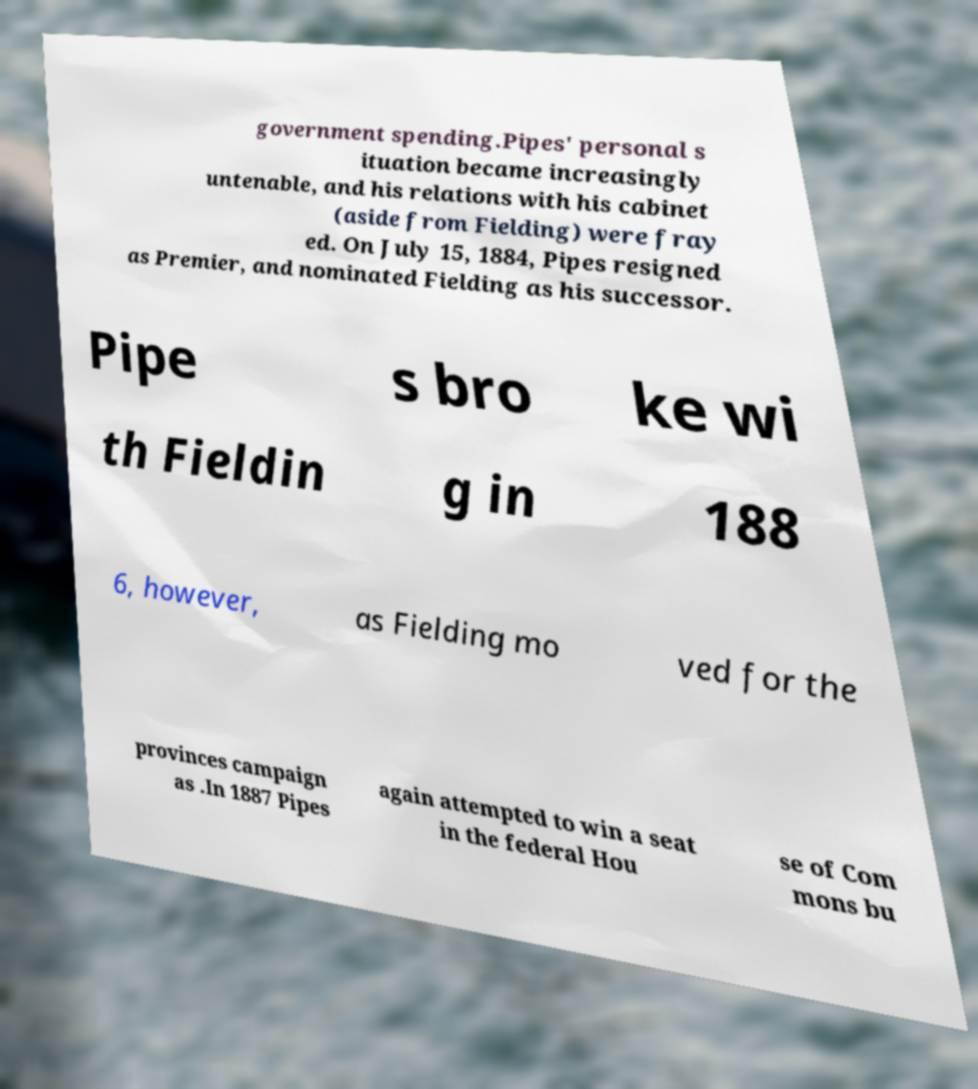Could you extract and type out the text from this image? government spending.Pipes' personal s ituation became increasingly untenable, and his relations with his cabinet (aside from Fielding) were fray ed. On July 15, 1884, Pipes resigned as Premier, and nominated Fielding as his successor. Pipe s bro ke wi th Fieldin g in 188 6, however, as Fielding mo ved for the provinces campaign as .In 1887 Pipes again attempted to win a seat in the federal Hou se of Com mons bu 